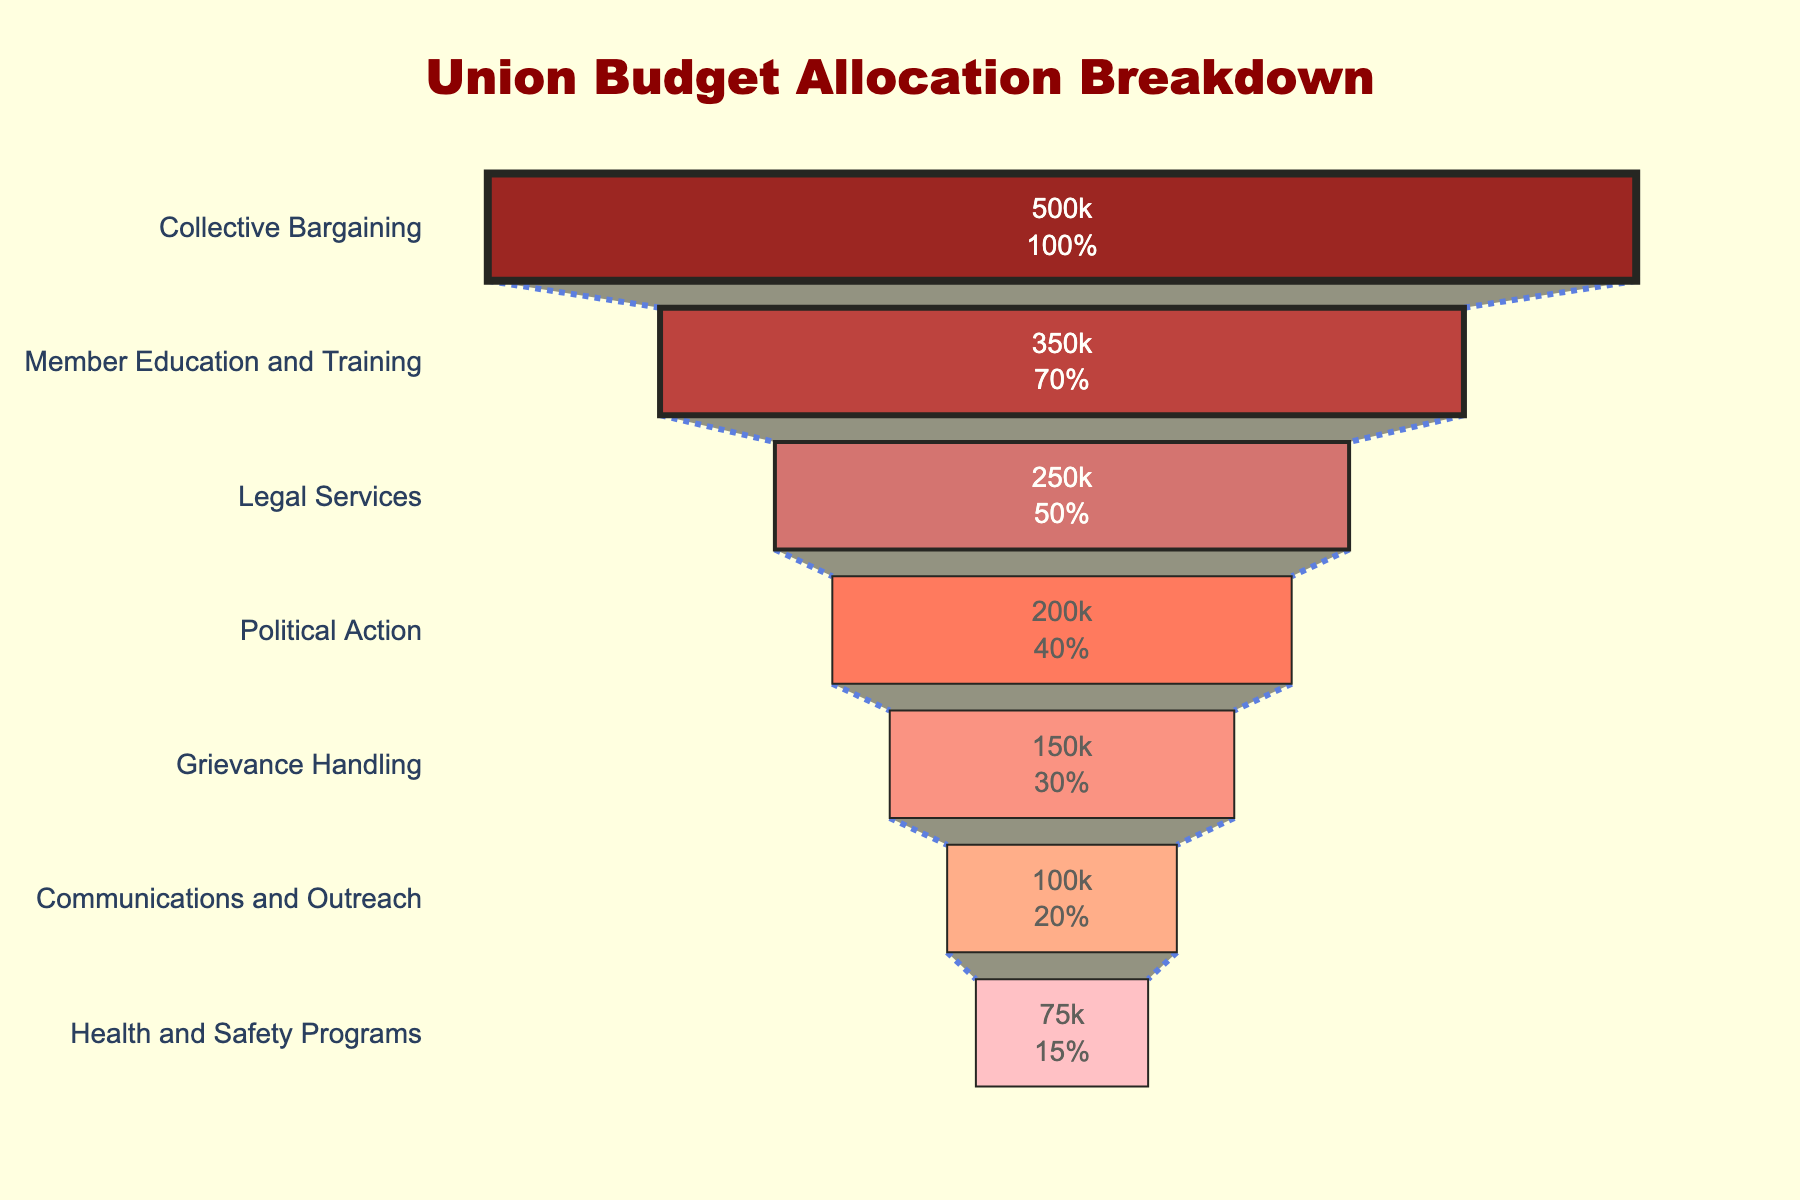What is the total budget allocated to Communications and Outreach? From the chart, we can see the section for Communications and Outreach clearly shows $100,000 as its allocated budget.
Answer: $100,000 Which category has the highest budget allocation? Collective Bargaining is at the top of the funnel, signifying it has the highest budget allocation of $500,000.
Answer: Collective Bargaining What percentage of the total budget is allocated to Member Education and Training? Member Education and Training is labeled as $350,000. To find the percentage of this budget relative to the total, calculate the sum of all budgets (500000 + 350000 + 250000 + 200000 + 150000 + 100000 + 75000 = 1625000). Then, divide the Member Education and Training budget by the total and multiply by 100: (350000 / 1625000) * 100 ≈ 21.54%.
Answer: 21.54% Compare the budget allocations for Political Action and Grievance Handling. Which one has more budget? From the chart, Political Action has a budget of $200,000 while Grievance Handling has $150,000. Therefore, Political Action has more budget allocation.
Answer: Political Action How much more budget is allocated to Legal Services compared to Health and Safety Programs? Legal Services has a budget of $250,000, and Health and Safety Programs has $75,000. Subtracting the latter from the former gives 250000 - 75000 = $175,000.
Answer: $175,000 What is the combined budget for Political Action and Communications and Outreach? Political Action and Communications and Outreach have budgets of $200,000 and $100,000 respectively. Summing these together gives 200000 + 100000 = $300,000.
Answer: $300,000 What is the percentage difference between the budgets of Collective Bargaining and Health and Safety Programs? Collective Bargaining is allocated $500,000 and Health and Safety Programs $75,000. The difference between these amounts is 500000 - 75000 = $425,000. To find the percentage difference relative to Health and Safety Programs: (425000 / 75000) * 100 ≈ 566.67%.
Answer: 566.67% Which category has the lowest budget allocation, and how much is it? Health and Safety Programs is at the bottom of the funnel chart, indicating it has the lowest budget allocation, which is $75,000.
Answer: Health and Safety Programs, $75,000 What is the average budget allocation across all categories? To find the average, sum all budget allocations (500000 + 350000 + 250000 + 200000 + 150000 + 100000 + 75000 = 1625000) and divide by the number of categories (7). Therefore, the average is 1625000 / 7 ≈ $232,142.86.
Answer: $232,142.86 